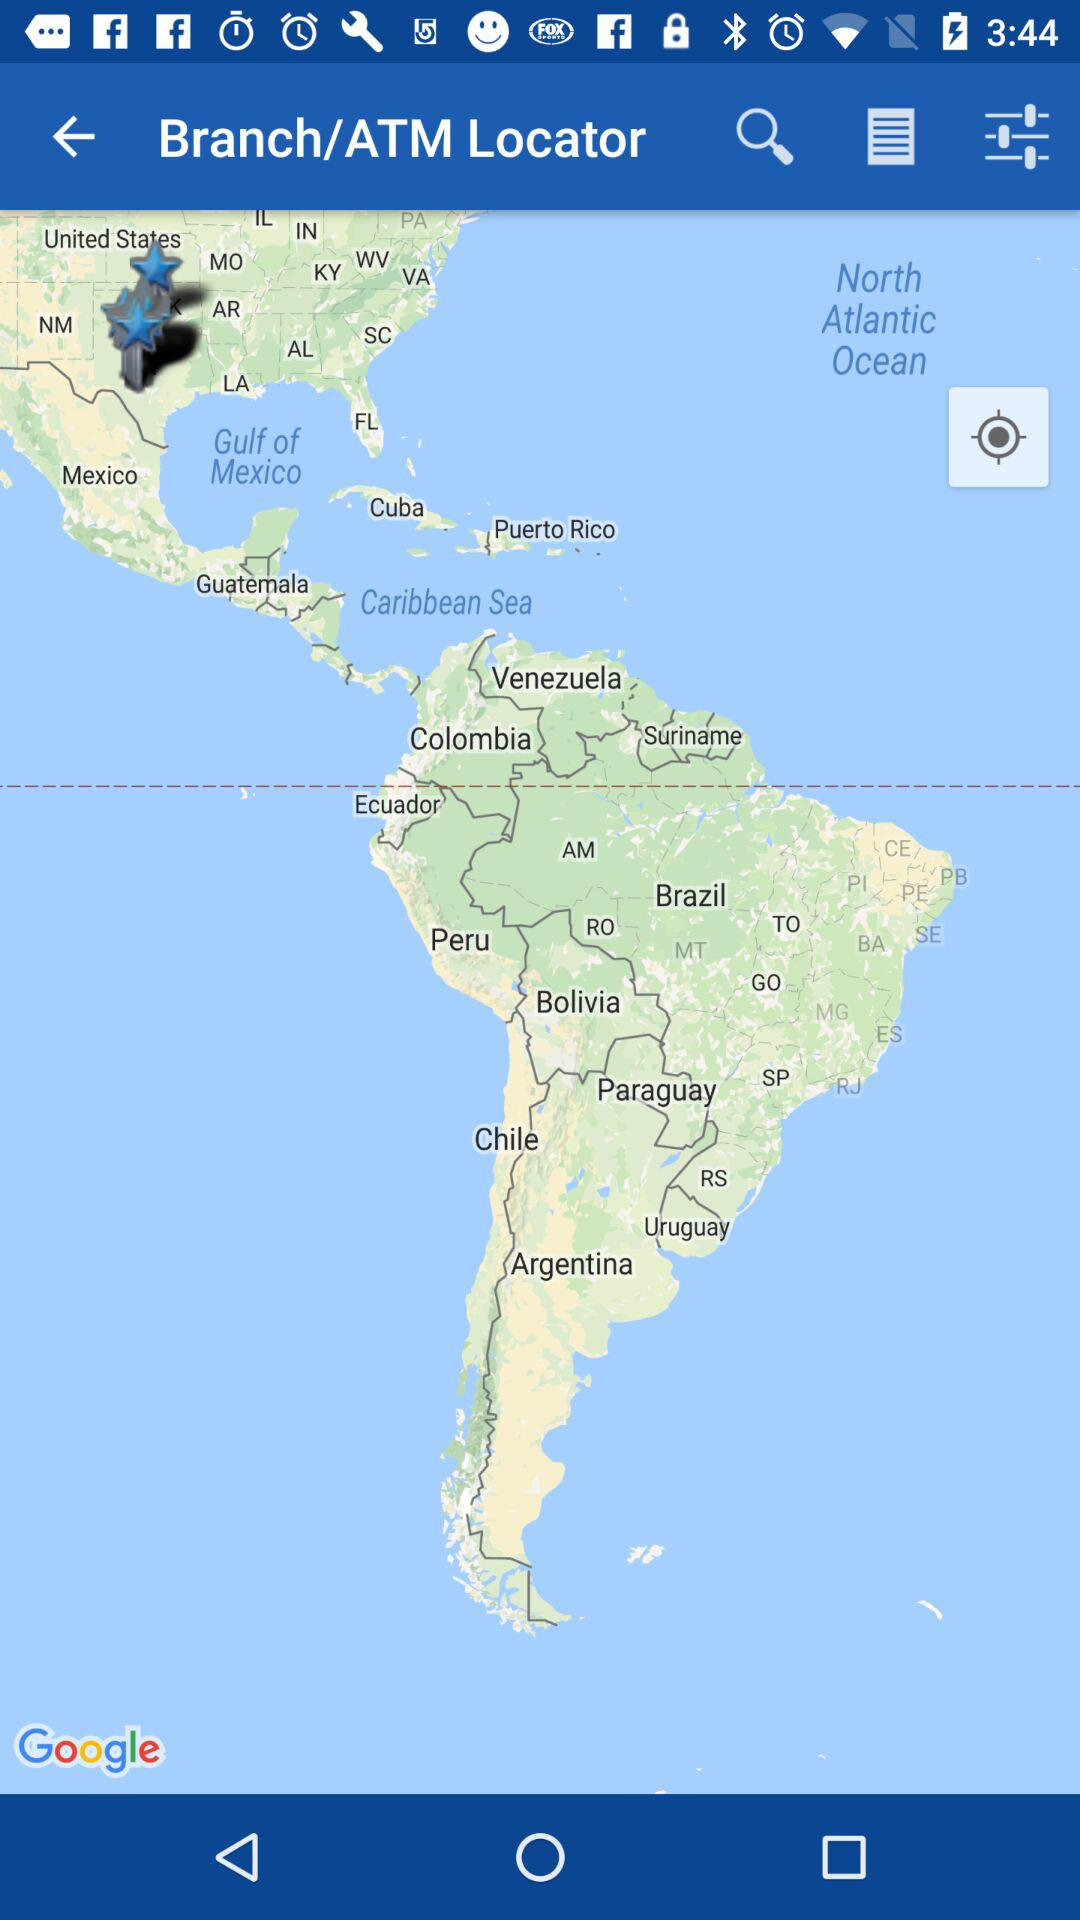What is the application name? The application name is "Branch/ATM Locator". 